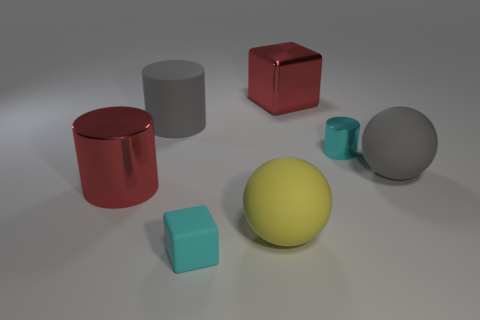Subtract all metal cylinders. How many cylinders are left? 1 Add 1 large yellow cylinders. How many objects exist? 8 Subtract all red blocks. How many blocks are left? 1 Add 6 matte objects. How many matte objects exist? 10 Subtract 1 red cubes. How many objects are left? 6 Subtract all cylinders. How many objects are left? 4 Subtract 2 cubes. How many cubes are left? 0 Subtract all brown balls. Subtract all purple cylinders. How many balls are left? 2 Subtract all gray spheres. How many red cubes are left? 1 Subtract all big rubber cylinders. Subtract all big red metallic cubes. How many objects are left? 5 